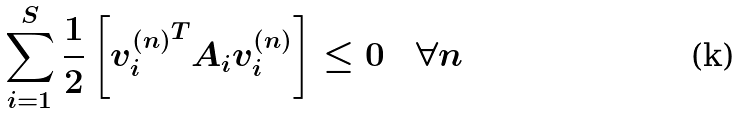Convert formula to latex. <formula><loc_0><loc_0><loc_500><loc_500>\sum _ { i = 1 } ^ { S } \frac { 1 } { 2 } \left [ { v ^ { ( n ) } _ { i } } ^ { T } A _ { i } v ^ { ( n ) } _ { i } \right ] \leq 0 \quad \forall n</formula> 